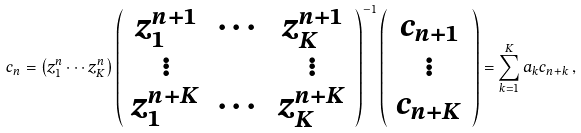Convert formula to latex. <formula><loc_0><loc_0><loc_500><loc_500>c _ { n } = \left ( z _ { 1 } ^ { n } \cdots z _ { K } ^ { n } \right ) \left ( \begin{array} { c c c } z _ { 1 } ^ { n + 1 } & \cdots & z _ { K } ^ { n + 1 } \\ \vdots & & \vdots \\ z _ { 1 } ^ { n + K } & \cdots & z _ { K } ^ { n + K } \end{array} \right ) ^ { - 1 } \left ( \begin{array} { c } c _ { n + 1 } \\ \vdots \\ c _ { n + K } \end{array} \right ) = \sum _ { k = 1 } ^ { K } a _ { k } c _ { n + k } \, ,</formula> 